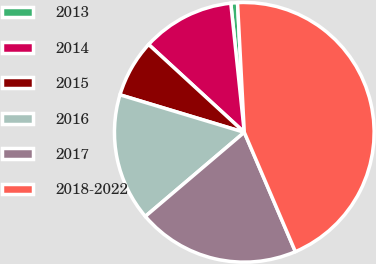<chart> <loc_0><loc_0><loc_500><loc_500><pie_chart><fcel>2013<fcel>2014<fcel>2015<fcel>2016<fcel>2017<fcel>2018-2022<nl><fcel>0.83%<fcel>11.52%<fcel>7.16%<fcel>15.87%<fcel>20.23%<fcel>44.39%<nl></chart> 